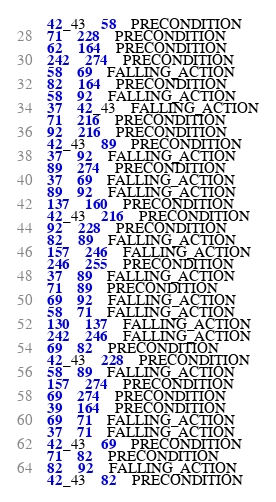<code> <loc_0><loc_0><loc_500><loc_500><_SQL_>42_43	58	PRECONDITION
71	228	PRECONDITION
62	164	PRECONDITION
242	274	PRECONDITION
58	69	FALLING_ACTION
82	164	PRECONDITION
58	92	FALLING_ACTION
37	42_43	FALLING_ACTION
71	216	PRECONDITION
92	216	PRECONDITION
42_43	89	PRECONDITION
37	92	FALLING_ACTION
89	274	PRECONDITION
37	69	FALLING_ACTION
89	92	FALLING_ACTION
137	160	PRECONDITION
42_43	216	PRECONDITION
92	228	PRECONDITION
82	89	FALLING_ACTION
157	246	FALLING_ACTION
246	255	PRECONDITION
37	89	FALLING_ACTION
71	89	PRECONDITION
69	92	FALLING_ACTION
58	71	FALLING_ACTION
130	137	FALLING_ACTION
242	246	FALLING_ACTION
69	82	PRECONDITION
42_43	228	PRECONDITION
58	89	FALLING_ACTION
157	274	PRECONDITION
69	274	PRECONDITION
39	164	PRECONDITION
69	71	FALLING_ACTION
37	71	FALLING_ACTION
42_43	69	PRECONDITION
71	82	PRECONDITION
82	92	FALLING_ACTION
42_43	82	PRECONDITION
</code> 